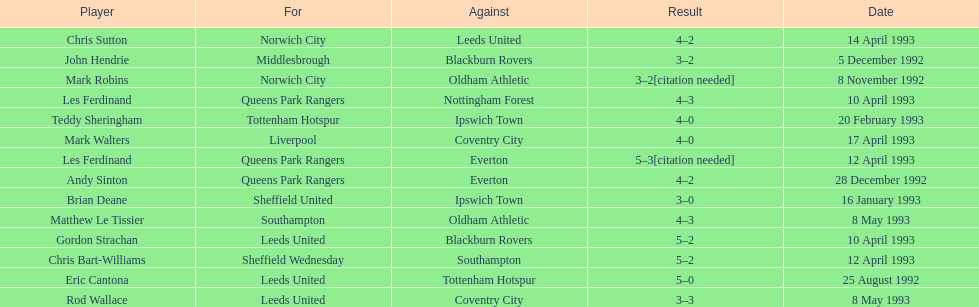What was the result of the match between queens park rangers and everton? 4-2. 